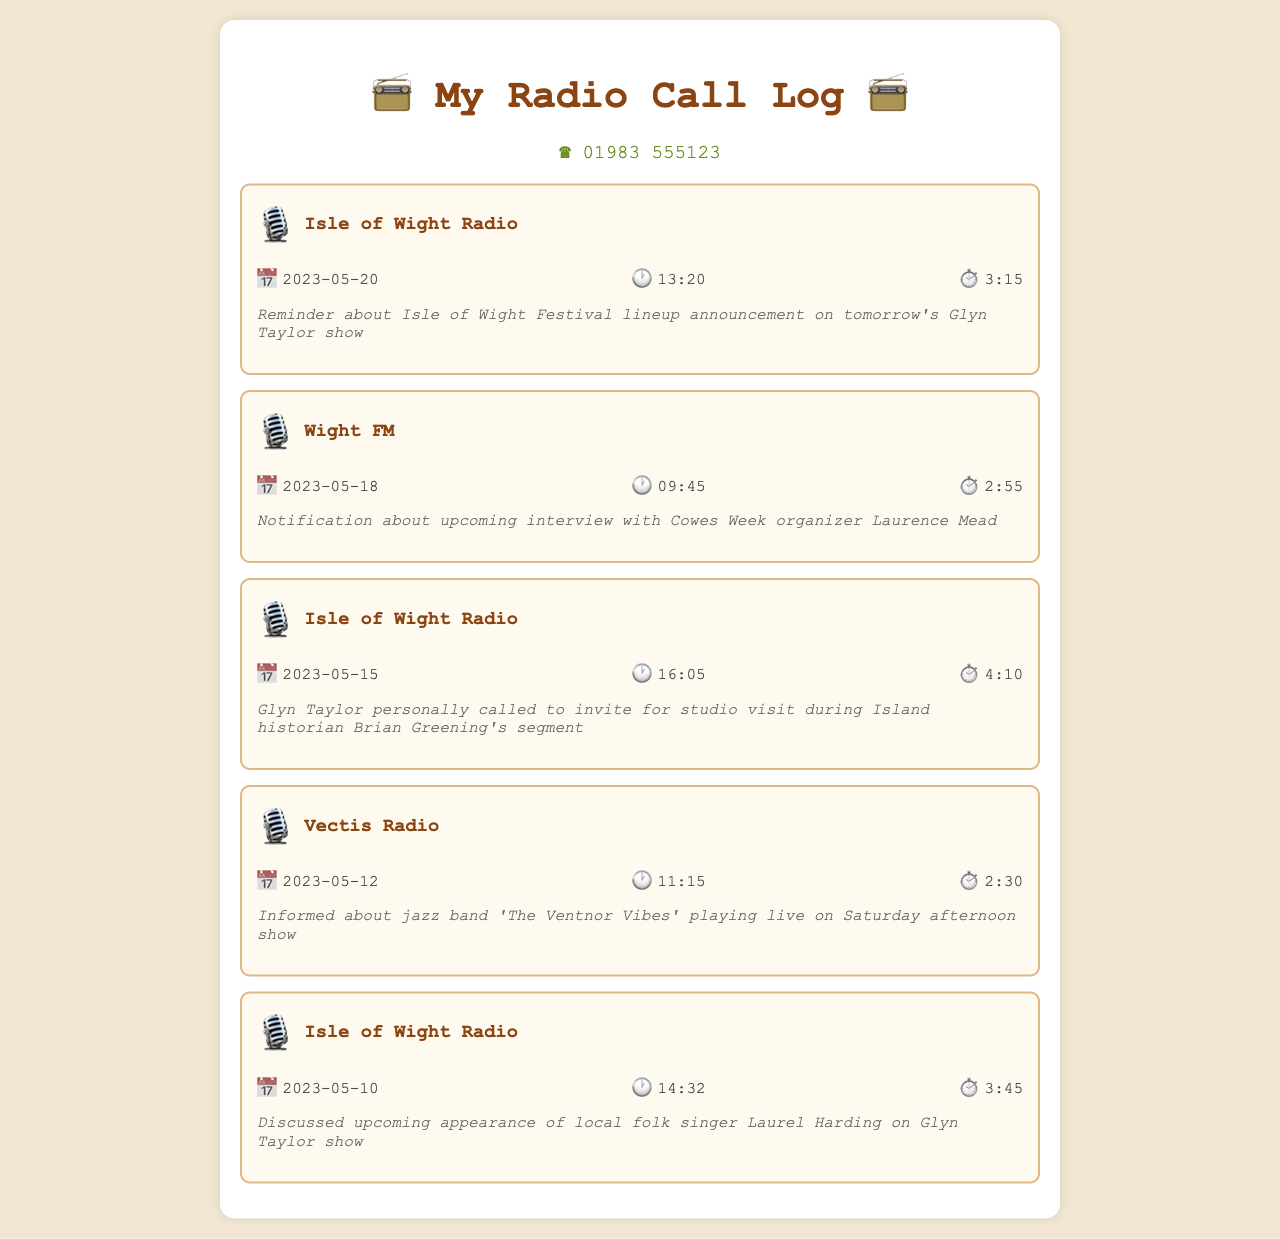What is the phone number? The phone number is displayed prominently at the top of the document as 01983 555123.
Answer: 01983 555123 What date was the call about the Isle of Wight Festival? The date of the call regarding the Isle of Wight Festival lineup announcement is found in the first call log entry, which is 2023-05-20.
Answer: 2023-05-20 Who was the guest mentioned for the upcoming interview? The call log provides information about an interview with Cowes Week organizer Laurence Mead, which is mentioned in the second call.
Answer: Laurence Mead What was the duration of the call about Laurel Harding? The duration for the call discussing Laurel Harding's appearance is listed in the fifth call log entry as 3:45.
Answer: 3:45 Which radio station called with news about a jazz band? The call log indicates that Vectis Radio informed about the jazz band 'The Ventnor Vibes' in the fourth entry.
Answer: Vectis Radio Which show is Glyn Taylor's call associated with? Glyn Taylor's call is associated with his own show, as referenced in the call where he invited a guest for a studio visit.
Answer: Glyn Taylor show How long was the call discussing the Cowes Week interview? The call about the Cowes Week interview lasted 2:55, as noted in the second call log entry.
Answer: 2:55 What type of music is featured in the mentioned live performance? The live performance mentioned in the call log is by a jazz band called 'The Ventnor Vibes', indicating it features jazz music.
Answer: Jazz 